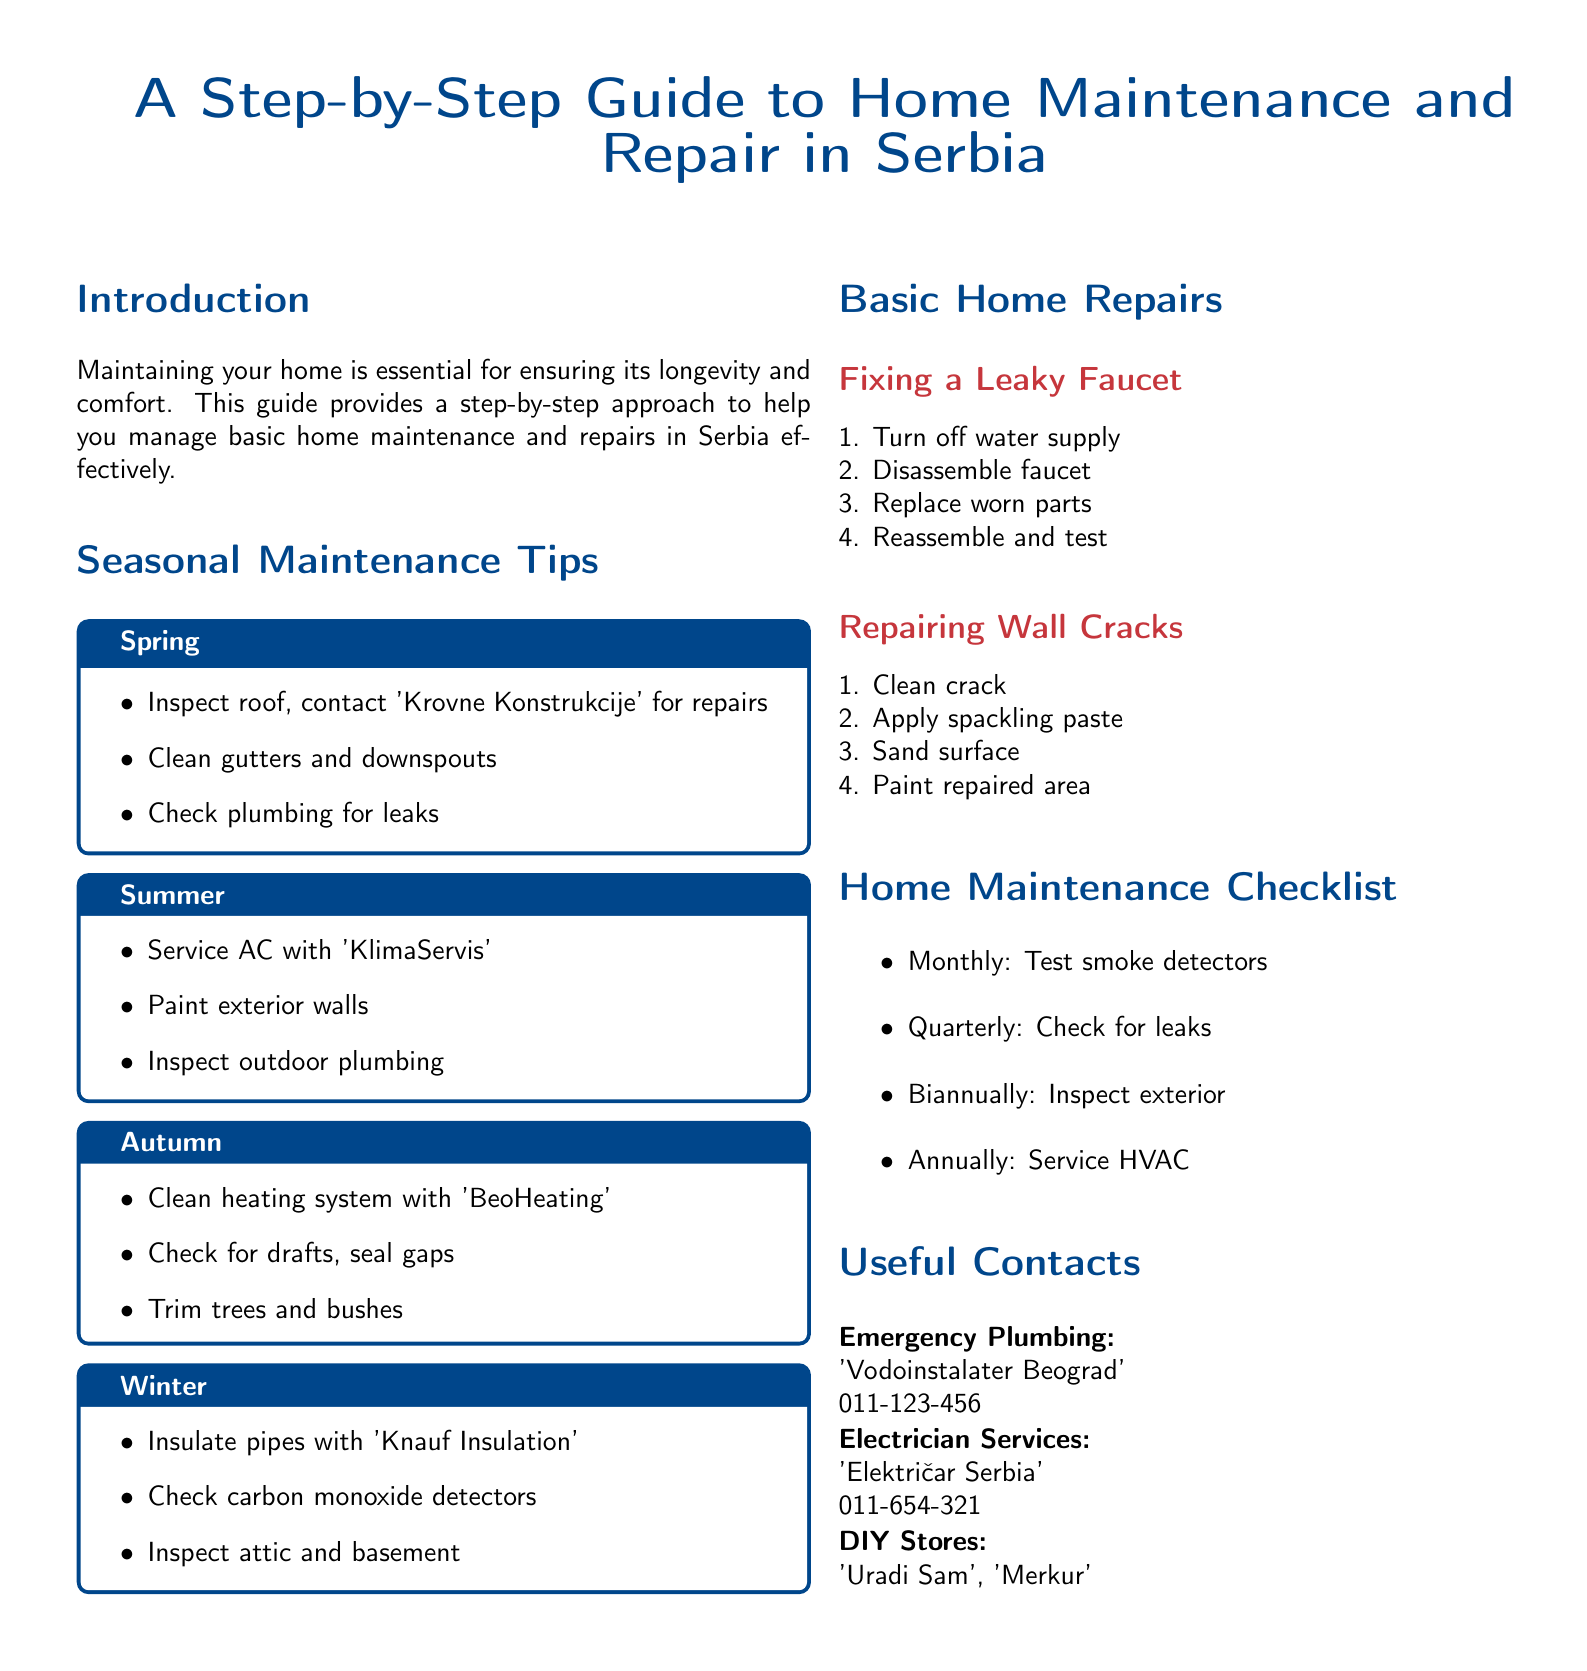What is the title of the guide? The title is explicitly stated at the top of the document.
Answer: A Step-by-Step Guide to Home Maintenance and Repair in Serbia Who should be contacted for roof repairs? The document specifies a contact for roof repairs in the spring section.
Answer: Krovne Konstrukcije What should you do in Autumn for home maintenance? The Autumn maintenance tips provide a specific set of tasks to be completed.
Answer: Clean heating system with 'BeoHeating' How often should smoke detectors be tested? The home maintenance checklist outlines the frequency for testing smoke detectors.
Answer: Monthly What is the phone number for emergency plumbing? The document provides a specific contact number for emergency plumbing services.
Answer: 011-123-456 How many steps are there to fix a leaky faucet? The repairs section outlines the process for fixing a leaky faucet and lists steps.
Answer: Four steps What type of paste is used to repair wall cracks? The basic home repairs section specifies what to use for wall crack repairs.
Answer: Spackling paste What should you do to check for drafts? The Autumn section mentions a specific maintenance task related to drafts.
Answer: Seal gaps 